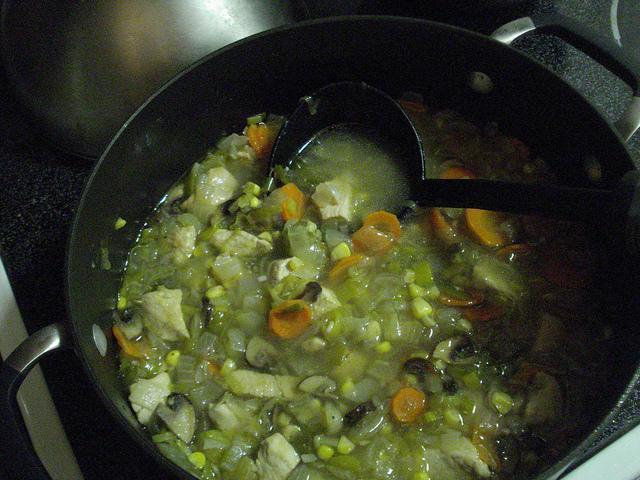How many broccolis are in the photo?
Give a very brief answer. 2. How many white horses are there?
Give a very brief answer. 0. 